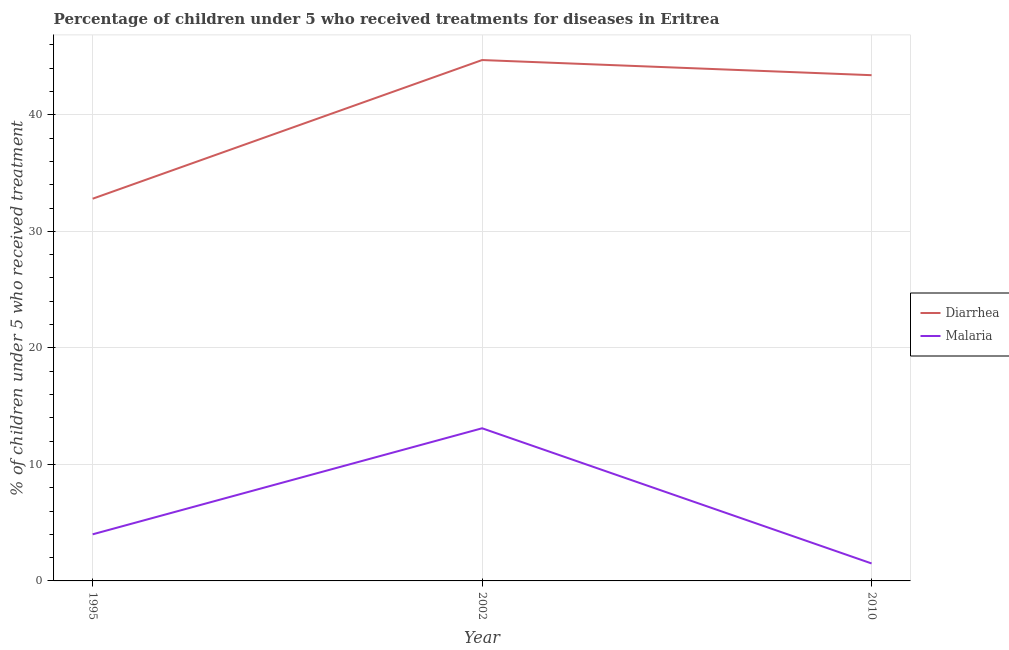Is the number of lines equal to the number of legend labels?
Your response must be concise. Yes. What is the percentage of children who received treatment for diarrhoea in 2002?
Provide a short and direct response. 44.7. Across all years, what is the maximum percentage of children who received treatment for diarrhoea?
Make the answer very short. 44.7. Across all years, what is the minimum percentage of children who received treatment for malaria?
Your answer should be compact. 1.5. In which year was the percentage of children who received treatment for diarrhoea maximum?
Your response must be concise. 2002. In which year was the percentage of children who received treatment for malaria minimum?
Your answer should be very brief. 2010. What is the total percentage of children who received treatment for diarrhoea in the graph?
Your answer should be compact. 120.9. What is the difference between the percentage of children who received treatment for malaria in 2002 and the percentage of children who received treatment for diarrhoea in 1995?
Give a very brief answer. -19.7. What is the average percentage of children who received treatment for malaria per year?
Keep it short and to the point. 6.2. In the year 2002, what is the difference between the percentage of children who received treatment for malaria and percentage of children who received treatment for diarrhoea?
Your answer should be very brief. -31.6. In how many years, is the percentage of children who received treatment for diarrhoea greater than 6 %?
Your answer should be very brief. 3. What is the ratio of the percentage of children who received treatment for diarrhoea in 1995 to that in 2010?
Your response must be concise. 0.76. Is the percentage of children who received treatment for malaria in 1995 less than that in 2010?
Your response must be concise. No. Is the sum of the percentage of children who received treatment for malaria in 1995 and 2010 greater than the maximum percentage of children who received treatment for diarrhoea across all years?
Your answer should be compact. No. How many lines are there?
Offer a very short reply. 2. Are the values on the major ticks of Y-axis written in scientific E-notation?
Offer a very short reply. No. Does the graph contain grids?
Give a very brief answer. Yes. Where does the legend appear in the graph?
Give a very brief answer. Center right. How many legend labels are there?
Offer a terse response. 2. What is the title of the graph?
Provide a succinct answer. Percentage of children under 5 who received treatments for diseases in Eritrea. What is the label or title of the Y-axis?
Make the answer very short. % of children under 5 who received treatment. What is the % of children under 5 who received treatment in Diarrhea in 1995?
Provide a succinct answer. 32.8. What is the % of children under 5 who received treatment in Malaria in 1995?
Your answer should be compact. 4. What is the % of children under 5 who received treatment in Diarrhea in 2002?
Your answer should be very brief. 44.7. What is the % of children under 5 who received treatment in Malaria in 2002?
Ensure brevity in your answer.  13.1. What is the % of children under 5 who received treatment of Diarrhea in 2010?
Make the answer very short. 43.4. What is the % of children under 5 who received treatment of Malaria in 2010?
Your response must be concise. 1.5. Across all years, what is the maximum % of children under 5 who received treatment of Diarrhea?
Ensure brevity in your answer.  44.7. Across all years, what is the maximum % of children under 5 who received treatment in Malaria?
Provide a short and direct response. 13.1. Across all years, what is the minimum % of children under 5 who received treatment of Diarrhea?
Offer a terse response. 32.8. Across all years, what is the minimum % of children under 5 who received treatment of Malaria?
Provide a succinct answer. 1.5. What is the total % of children under 5 who received treatment in Diarrhea in the graph?
Offer a very short reply. 120.9. What is the difference between the % of children under 5 who received treatment in Malaria in 1995 and that in 2002?
Your answer should be very brief. -9.1. What is the difference between the % of children under 5 who received treatment in Malaria in 1995 and that in 2010?
Keep it short and to the point. 2.5. What is the difference between the % of children under 5 who received treatment in Diarrhea in 1995 and the % of children under 5 who received treatment in Malaria in 2002?
Offer a terse response. 19.7. What is the difference between the % of children under 5 who received treatment of Diarrhea in 1995 and the % of children under 5 who received treatment of Malaria in 2010?
Keep it short and to the point. 31.3. What is the difference between the % of children under 5 who received treatment in Diarrhea in 2002 and the % of children under 5 who received treatment in Malaria in 2010?
Your response must be concise. 43.2. What is the average % of children under 5 who received treatment of Diarrhea per year?
Offer a terse response. 40.3. What is the average % of children under 5 who received treatment in Malaria per year?
Your response must be concise. 6.2. In the year 1995, what is the difference between the % of children under 5 who received treatment of Diarrhea and % of children under 5 who received treatment of Malaria?
Offer a terse response. 28.8. In the year 2002, what is the difference between the % of children under 5 who received treatment of Diarrhea and % of children under 5 who received treatment of Malaria?
Give a very brief answer. 31.6. In the year 2010, what is the difference between the % of children under 5 who received treatment of Diarrhea and % of children under 5 who received treatment of Malaria?
Offer a very short reply. 41.9. What is the ratio of the % of children under 5 who received treatment in Diarrhea in 1995 to that in 2002?
Give a very brief answer. 0.73. What is the ratio of the % of children under 5 who received treatment of Malaria in 1995 to that in 2002?
Offer a very short reply. 0.31. What is the ratio of the % of children under 5 who received treatment in Diarrhea in 1995 to that in 2010?
Your response must be concise. 0.76. What is the ratio of the % of children under 5 who received treatment of Malaria in 1995 to that in 2010?
Give a very brief answer. 2.67. What is the ratio of the % of children under 5 who received treatment in Malaria in 2002 to that in 2010?
Make the answer very short. 8.73. What is the difference between the highest and the second highest % of children under 5 who received treatment in Diarrhea?
Offer a terse response. 1.3. What is the difference between the highest and the lowest % of children under 5 who received treatment in Diarrhea?
Offer a terse response. 11.9. What is the difference between the highest and the lowest % of children under 5 who received treatment in Malaria?
Make the answer very short. 11.6. 